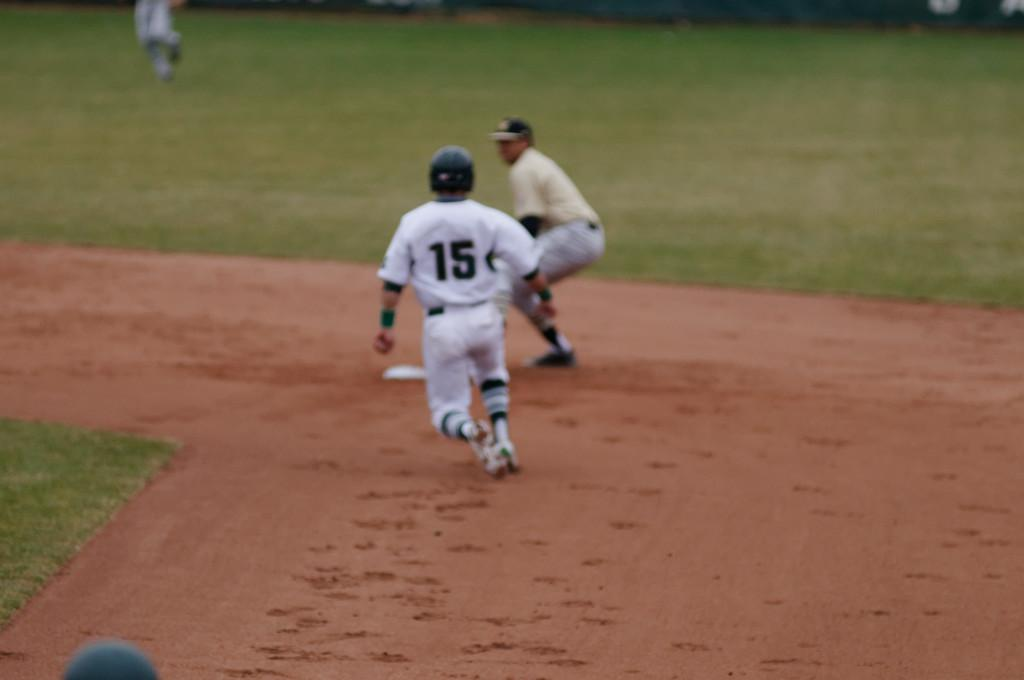Provide a one-sentence caption for the provided image. A baseball player with the number 15 on his back runs to a base. 